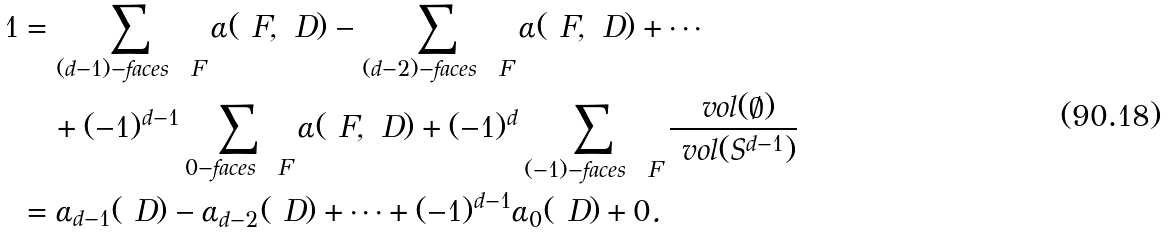Convert formula to latex. <formula><loc_0><loc_0><loc_500><loc_500>1 & = \sum _ { ( d - 1 ) - \text {faces } \ F } \alpha ( \ F , \ D ) - \sum _ { ( d - 2 ) - \text {faces } \ F } \alpha ( \ F , \ D ) + \cdots \\ & \quad + ( - 1 ) ^ { d - 1 } \sum _ { 0 - \text {faces } \ F } \alpha ( \ F , \ D ) + ( - 1 ) ^ { d } \sum _ { ( - 1 ) - \text {faces } \ F } \frac { \ v o l ( \emptyset ) } { \ v o l ( S ^ { d - 1 } ) } \\ & = \alpha _ { d - 1 } ( \ D ) - \alpha _ { d - 2 } ( \ D ) + \cdots + ( - 1 ) ^ { d - 1 } \alpha _ { 0 } ( \ D ) + 0 .</formula> 